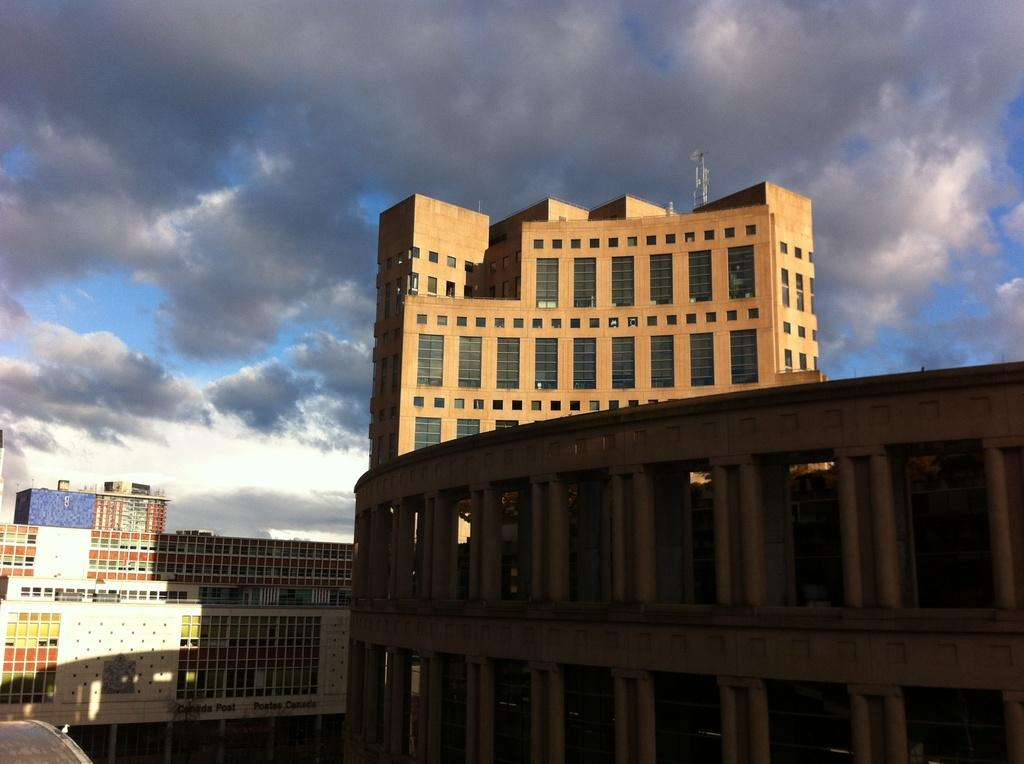What structures can be seen on the right side of the image? There are buildings on the right side of the image. What structures can be seen on the left side of the image? There are buildings on the left side of the image. What is visible at the top of the image? The sky is visible at the top of the image. What type of straw is used to clean the toothpaste in the image? There is no straw or toothpaste present in the image. 